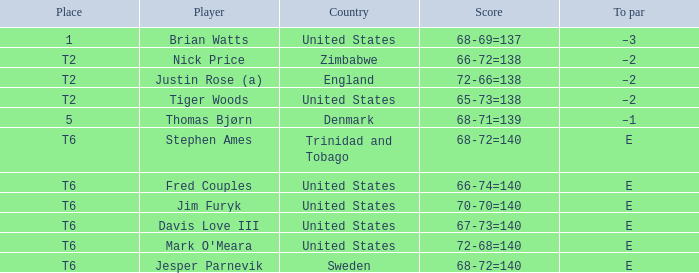In which position was tiger woods of the united states? T2. 